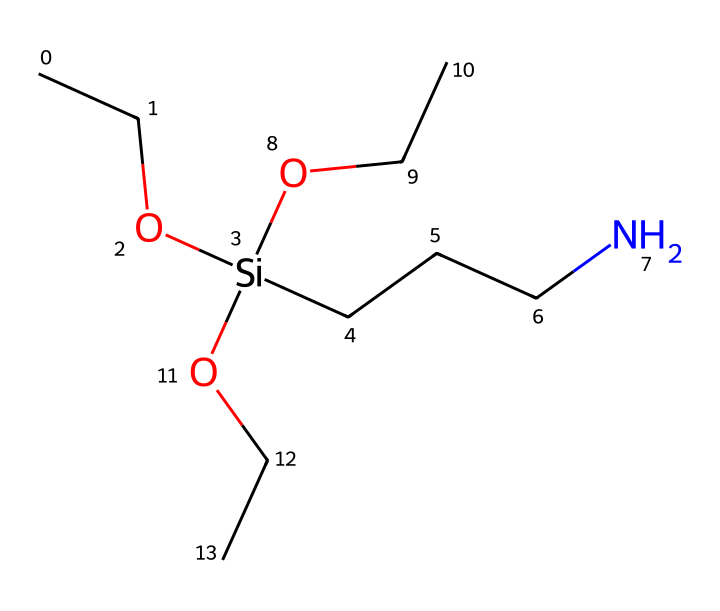What is the total number of carbon atoms in this silane coupling agent? By examining the SMILES representation, each "C" denotes a carbon atom. In the SMILES, there are 4 "C" characters indicating 4 carbon atoms in the structure.
Answer: 4 How many oxygen atoms are present in this silane structure? The SMILES representation includes the letter "O," which signifies oxygen atoms. There are 3 occurrences of "O" in the structure, meaning there are 3 oxygen atoms.
Answer: 3 What is the type of the silicon atom in this compound? The silicon atom appears as '[Si]' in the SMILES, suggesting it is covalently bonded to other atoms, characterizing this compound as a silane.
Answer: silane How many nitrogen atoms are found in this chemical? The nitrogen atom is represented by "N" in the SMILES. There is a single "N" present, indicating that there is 1 nitrogen atom in this silane coupling agent.
Answer: 1 What functional groups can be identified in this silane? The presence of –OH groups (hydroxyl) is indicated by "O" next to "C", especially in the part where "OCC" is present, which identifies it as an alcohol. Also, the presence of CCCN indicates an amine group, contributing to its functionality.
Answer: alcohol, amine What role does the silicon atom play in the structure of this compound? Silicon acts as a central atom that links various organic functional groups to enhance adhesion properties in materials such as netball shoe manufacturing, essential for bonding with various substrates.
Answer: adhesion agent What would be the molecular structure's main application in netball shoe manufacturing? The primary purpose of silane coupling agents is to promote adhesion between different materials, such as rubber and textiles found in netball shoes, thereby improving performance and durability.
Answer: adhesion promoter 